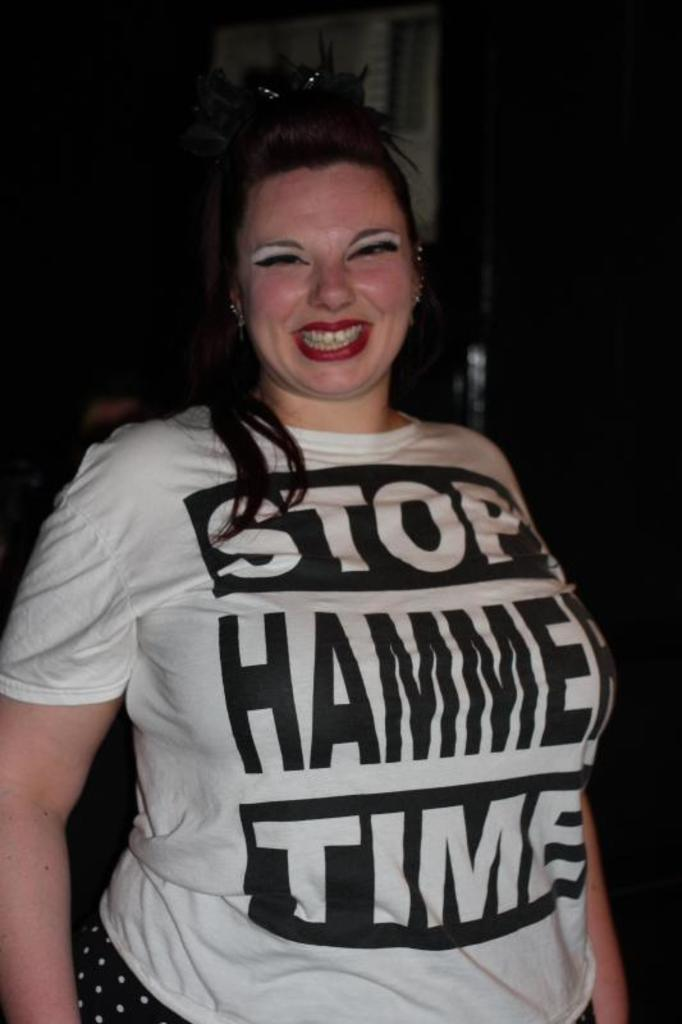<image>
Relay a brief, clear account of the picture shown. A woman wearing a white and black "Stop Hammer Time" t-shirt. 